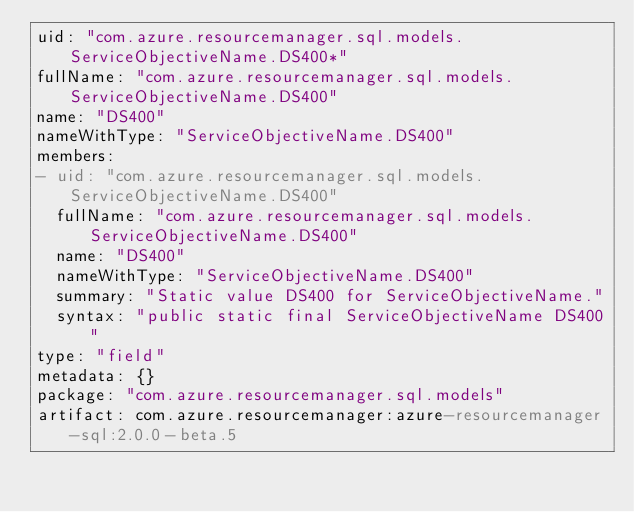Convert code to text. <code><loc_0><loc_0><loc_500><loc_500><_YAML_>uid: "com.azure.resourcemanager.sql.models.ServiceObjectiveName.DS400*"
fullName: "com.azure.resourcemanager.sql.models.ServiceObjectiveName.DS400"
name: "DS400"
nameWithType: "ServiceObjectiveName.DS400"
members:
- uid: "com.azure.resourcemanager.sql.models.ServiceObjectiveName.DS400"
  fullName: "com.azure.resourcemanager.sql.models.ServiceObjectiveName.DS400"
  name: "DS400"
  nameWithType: "ServiceObjectiveName.DS400"
  summary: "Static value DS400 for ServiceObjectiveName."
  syntax: "public static final ServiceObjectiveName DS400"
type: "field"
metadata: {}
package: "com.azure.resourcemanager.sql.models"
artifact: com.azure.resourcemanager:azure-resourcemanager-sql:2.0.0-beta.5
</code> 